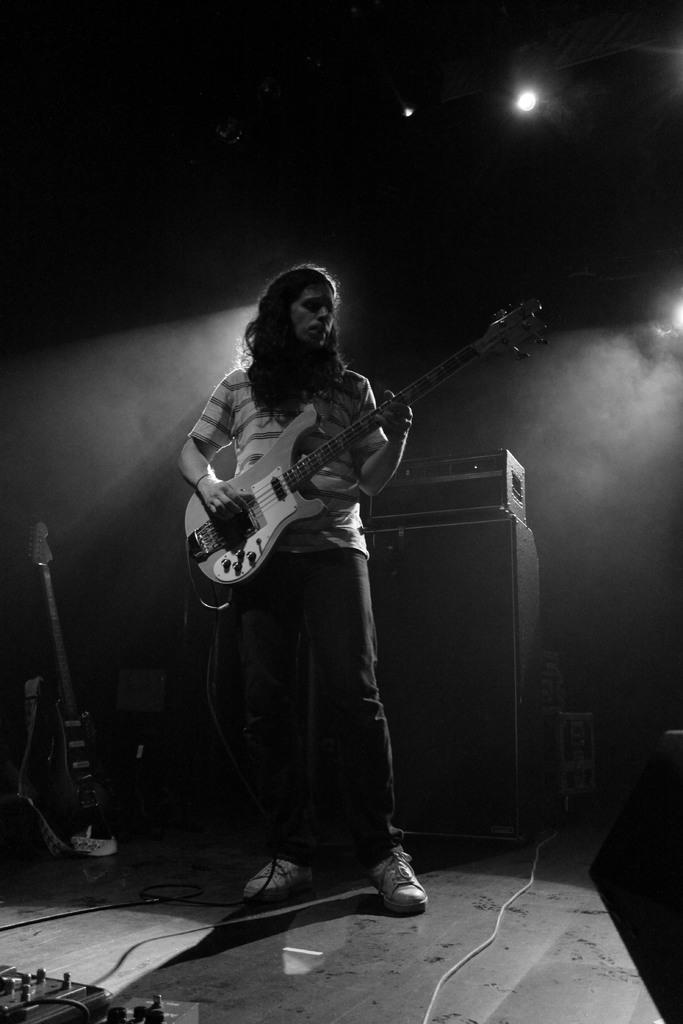What is the man in the image doing? The man is playing a guitar. Where is the man located in the image? The man is on a stage. What type of hot beverage is the man drinking while playing the guitar? There is no hot beverage present in the image; the man is playing a guitar on a stage. What type of crown is the man wearing while playing the guitar? There is no crown present in the image; the man is playing a guitar on a stage. 